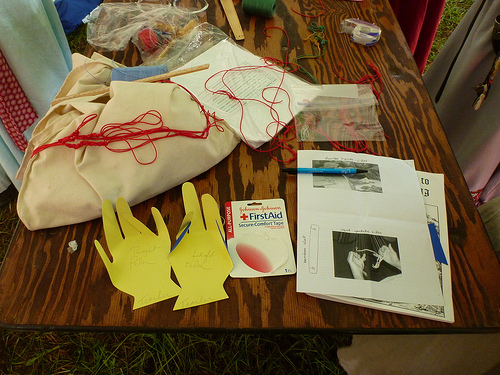<image>
Is the tape on the table? Yes. Looking at the image, I can see the tape is positioned on top of the table, with the table providing support. 